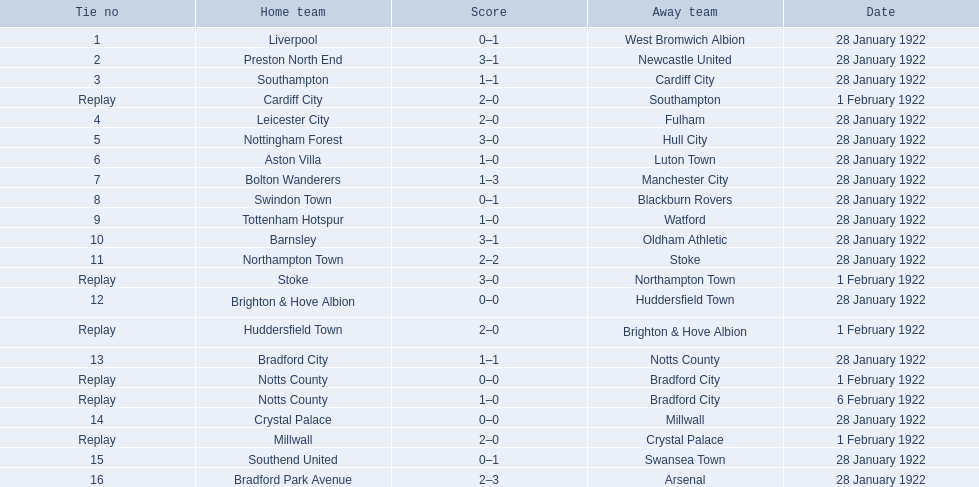Which team had a score of 0-1? Liverpool. Which team had a replay? Cardiff City. Which team had the same score as aston villa? Tottenham Hotspur. 